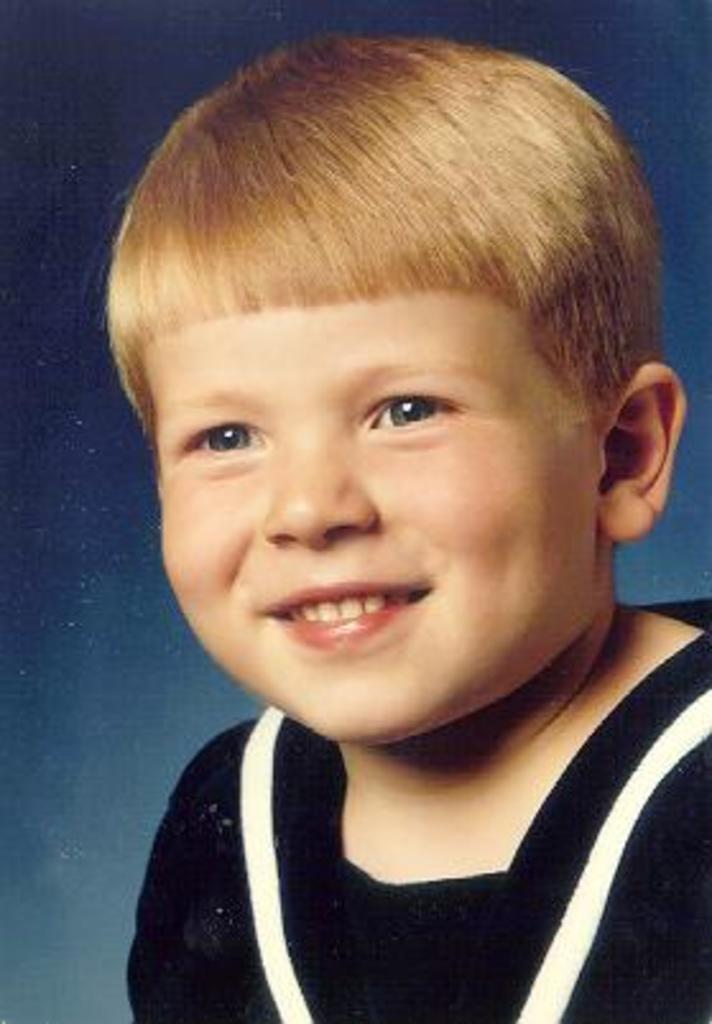What is the main subject of the image? The main subject of the image is a boy. What is the boy doing in the image? The boy is smiling in the image. What type of guitar is the boy playing in the image? There is no guitar present in the image; the boy is simply smiling. 